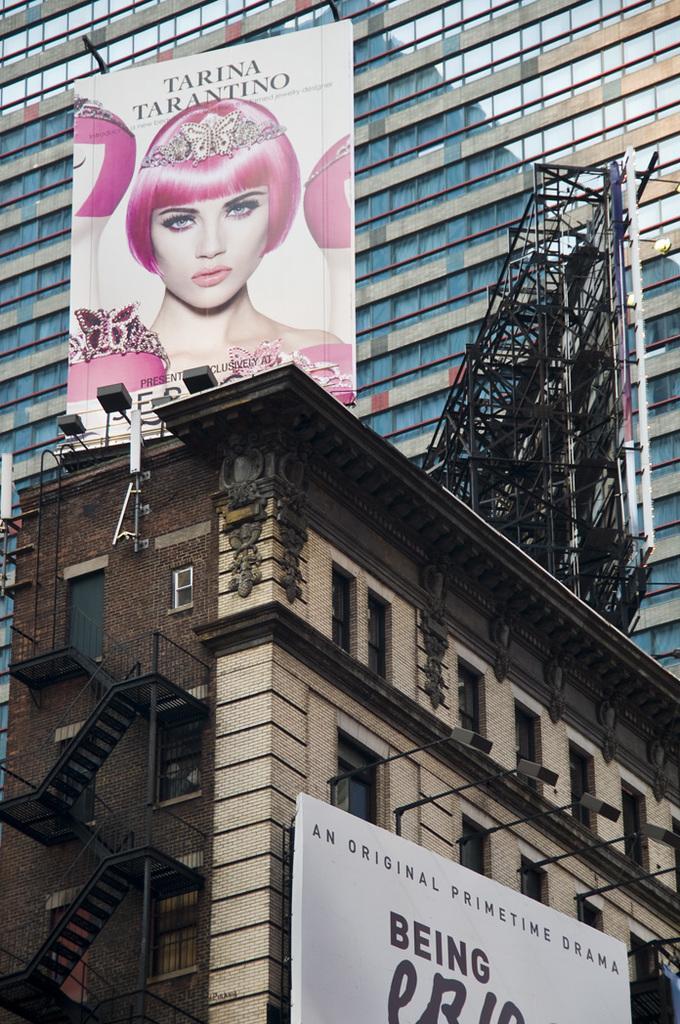Describe this image in one or two sentences. In this picture I can see the stairs on the left side. There are banners and buildings. 